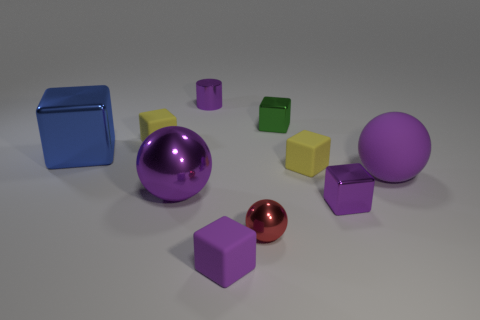Subtract all blue blocks. How many blocks are left? 5 Subtract all red spheres. How many spheres are left? 2 Subtract all blocks. How many objects are left? 4 Subtract all blue cylinders. How many yellow cubes are left? 2 Subtract 6 cubes. How many cubes are left? 0 Subtract all red spheres. Subtract all red blocks. How many spheres are left? 2 Subtract all small purple cubes. Subtract all big metallic spheres. How many objects are left? 7 Add 3 big blue metallic cubes. How many big blue metallic cubes are left? 4 Add 6 small metal cylinders. How many small metal cylinders exist? 7 Subtract 0 red cylinders. How many objects are left? 10 